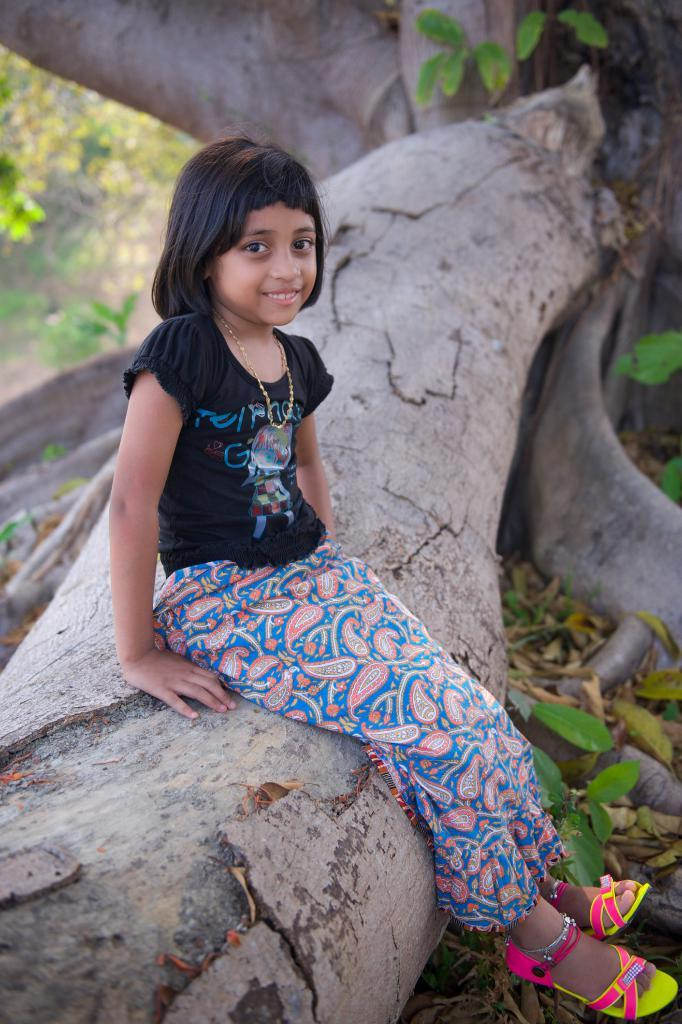Who is present in the image? There is a girl in the image. What is the girl wearing? The girl is wearing clothes, a neck chain, and sandals. She is also wearing an ankle chain. What is the girl doing in the image? The girl is sitting on a wooden log and smiling. What can be seen in the background of the image? Leaves and tree branches are visible in the image. What invention is the girl holding in her hand in the image? There is no invention visible in the girl's hand in the image. 